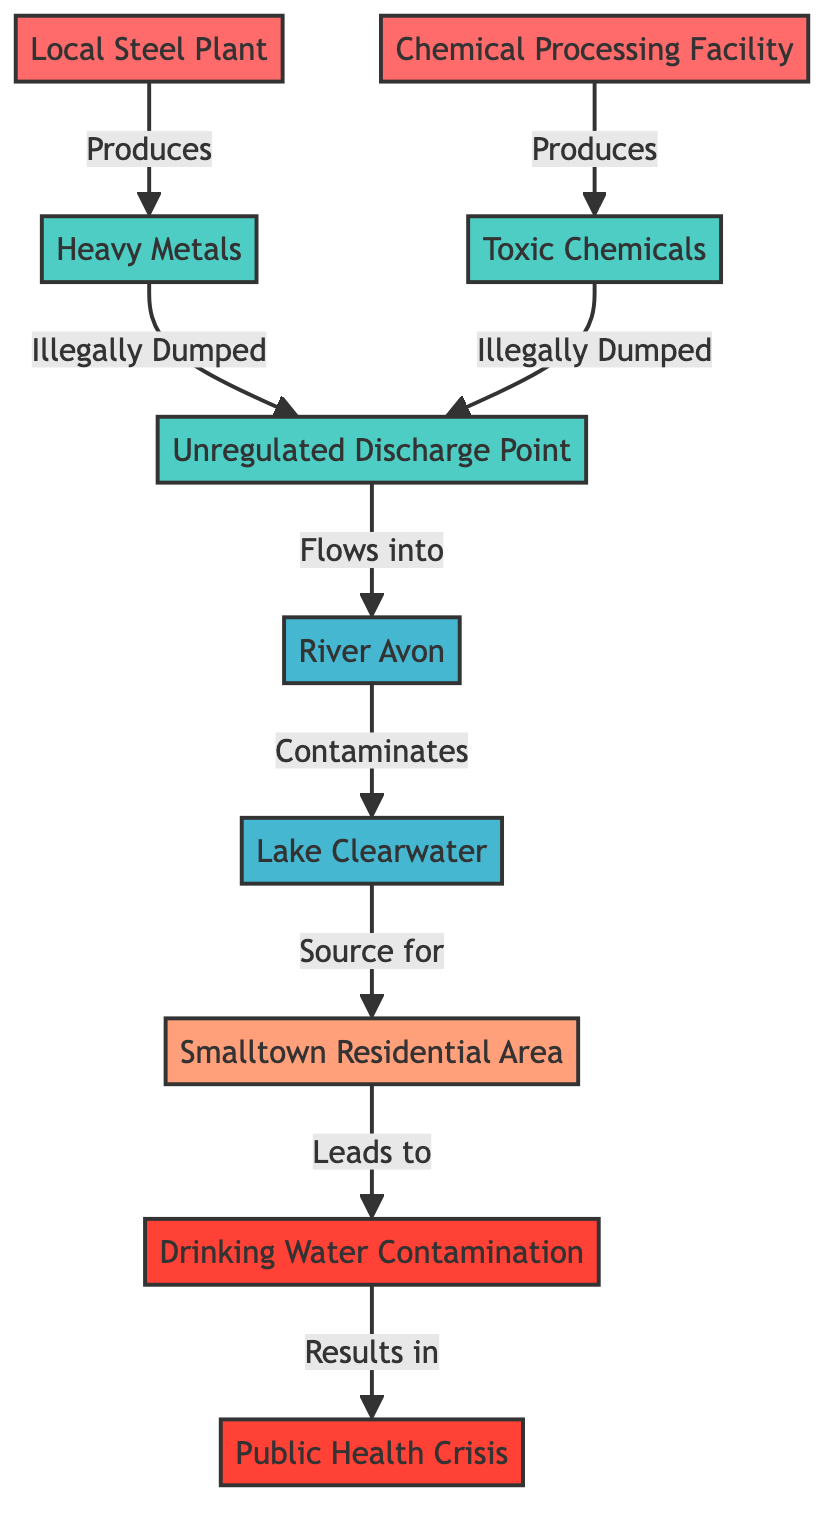What are the two types of waste produced by the factories? The diagram explicitly shows two types of waste: "Heavy Metals" from the Local Steel Plant and "Toxic Chemicals" from the Chemical Processing Facility.
Answer: Heavy Metals, Toxic Chemicals How many factories are shown in the diagram? By counting the nodes labeled as factories, we identify two: "Local Steel Plant" and "Chemical Processing Facility."
Answer: 2 What body of water is contaminated by waste from the discharge point? The diagram indicates that the waste flows from the discharge point into the "River Avon" and subsequently contaminates "Lake Clearwater." Thus, the body of water directly contaminated is "Lake Clearwater."
Answer: Lake Clearwater Who is affected by the health impacts of drinking water contamination? The diagram connects "Smalltown Residential Area" with "Drinking Water Contamination" leading to a "Public Health Crisis," indicating that the residents of Smalltown are affected.
Answer: Smalltown Residential Area What is the first step in the sequence of contamination? The sequence begins with the "Local Steel Plant" producing "Heavy Metals," which are then illegally dumped at the "Unregulated Discharge Point," making it the first step in the flow of contamination.
Answer: Local Steel Plant What happens after the river is contaminated? Following the contamination of "River Avon," the next step shown in the diagram is that it flows into "Lake Clearwater."
Answer: Flows into Lake Clearwater What leads to a public health crisis? The diagram shows that "Drinking Water Contamination" results in a "Public Health Crisis," indicating that it is the contamination of drinking water that leads to the health crisis.
Answer: Drinking Water Contamination What does the Community of Smalltown rely on for drinking water? The diagram illustrates that "Lake Clearwater" is the source for the "Smalltown Residential Area," signifying that they rely on it for their drinking water.
Answer: Lake Clearwater 